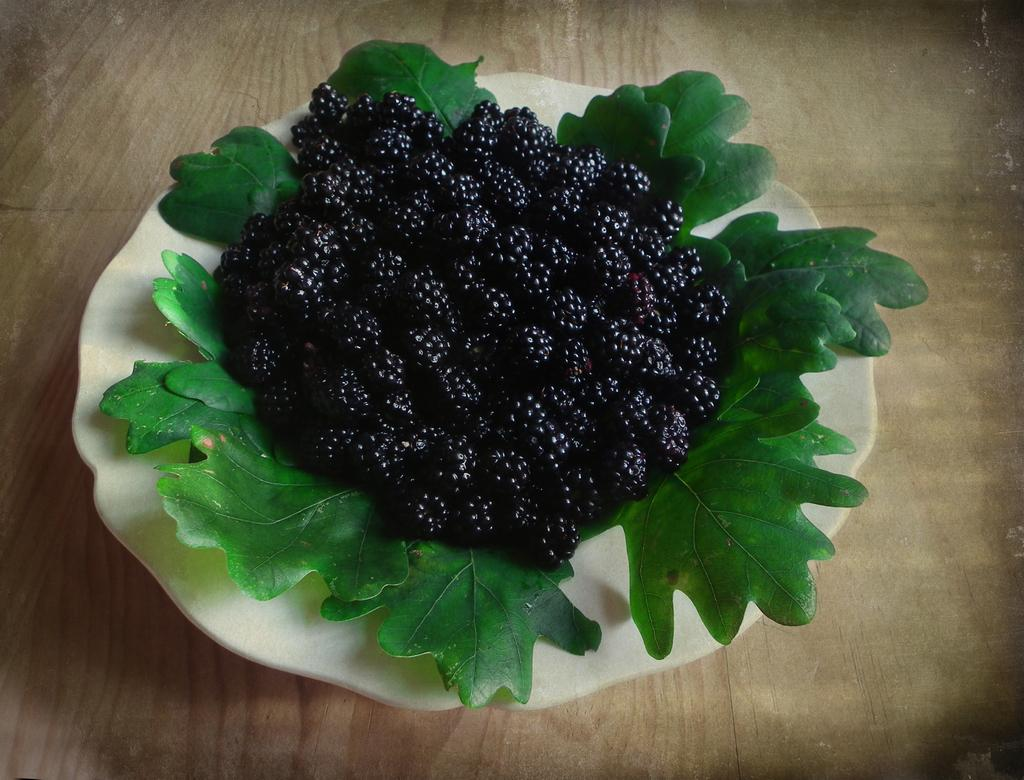What is the main object in the center of the image? There is a platter in the center of the image. What is on the platter? The platter contains berries and green leaves. What type of surface is visible in the background of the image? There is a wooden table in the background of the image. How many writers are present in the image? There are no writers present in the image; it features a platter with berries and green leaves on a wooden table. 